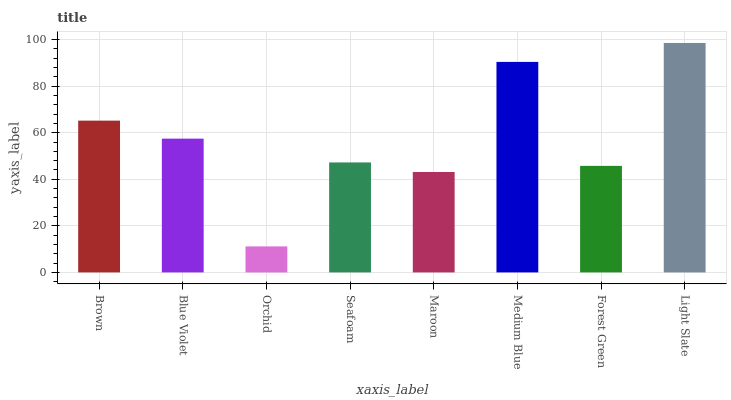Is Orchid the minimum?
Answer yes or no. Yes. Is Light Slate the maximum?
Answer yes or no. Yes. Is Blue Violet the minimum?
Answer yes or no. No. Is Blue Violet the maximum?
Answer yes or no. No. Is Brown greater than Blue Violet?
Answer yes or no. Yes. Is Blue Violet less than Brown?
Answer yes or no. Yes. Is Blue Violet greater than Brown?
Answer yes or no. No. Is Brown less than Blue Violet?
Answer yes or no. No. Is Blue Violet the high median?
Answer yes or no. Yes. Is Seafoam the low median?
Answer yes or no. Yes. Is Forest Green the high median?
Answer yes or no. No. Is Blue Violet the low median?
Answer yes or no. No. 